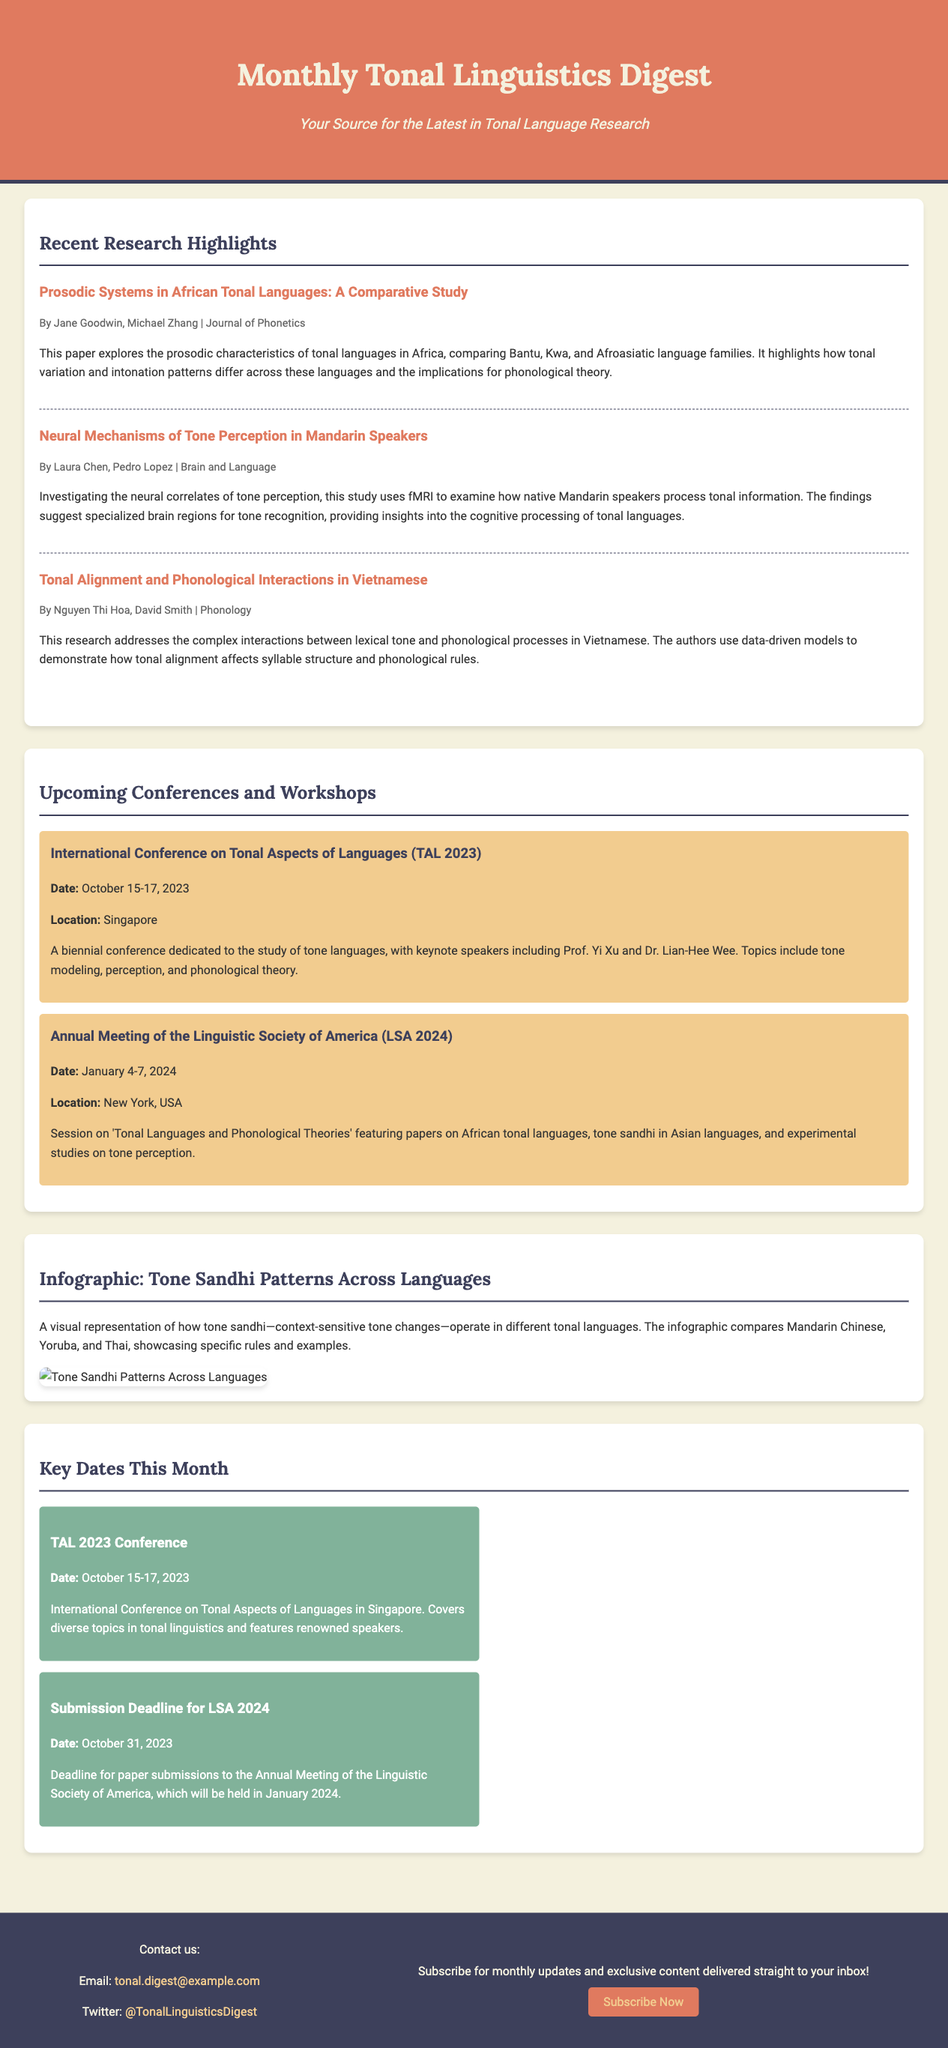What is the title of the newsletter? The title of the newsletter is stated at the top of the document, summarizing its focus.
Answer: Monthly Tonal Linguistics Digest Who authored the article on prosodic systems? The authors of this article are mentioned under its title, indicating their contributions.
Answer: Jane Goodwin, Michael Zhang What are the dates for the TAL 2023 conference? The specific dates for the conference are provided in the document under the conference section.
Answer: October 15-17, 2023 Which language families are compared in the study on prosodic systems? The document explicitly mentions the language families involved in the study of prosodic systems.
Answer: Bantu, Kwa, Afroasiatic What is the main focus of the infographic in the newsletter? The infographic's focus is detailed in the section text, explaining its content.
Answer: Tone Sandhi Patterns Across Languages When is the submission deadline for LSA 2024? The specific deadline date is given in the calendar section of the document.
Answer: October 31, 2023 Where will the LSA 2024 conference be held? The location is mentioned in the upcoming conferences section, providing essential information.
Answer: New York, USA Which university is Dr. Lian-Hee Wee affiliated with? The document mentions the keynote speakers but does not specify their affiliations. However, this could be a typical follow-up question.
Answer: (Not provided) Why is understanding tonal alignment important in Vietnamese? The reasoning section of the summary describes the significance of tonal alignment for phonological processes.
Answer: Affects syllable structure and phonological rules What type of content can subscribers expect in the newsletter? The footer section of the document highlights what the newsletter offers to subscribers.
Answer: Monthly updates and exclusive content 